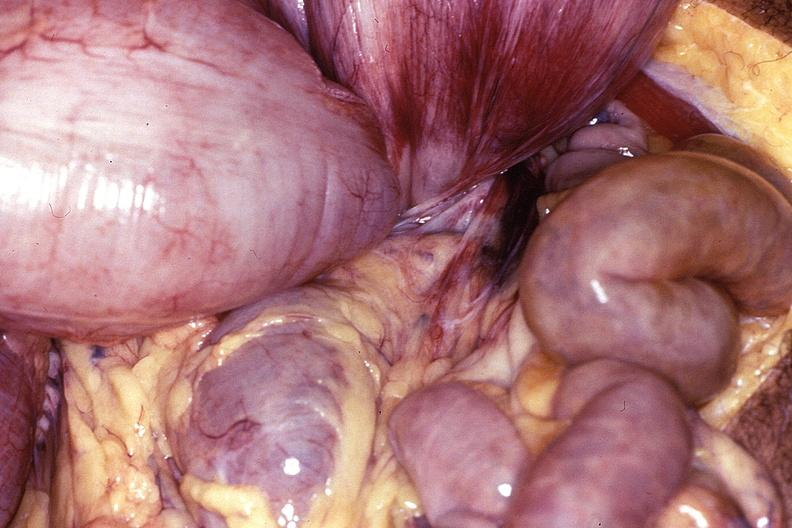where does this belong to?
Answer the question using a single word or phrase. Gastrointestinal system 